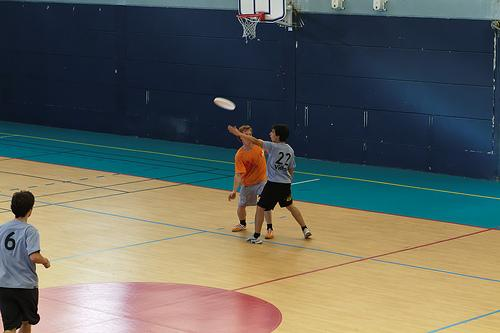What numbers are visible on the boys' shirts? Number 22 is on one boy's shirt, and number 6 is on the other boy's shirt. Give a simple description of the playing area. The playing area has a wooden, blue, red and green gymnasium floor, a green boundary line, and blue bleachers folded against the wall. Describe the scene involving the basketball hoop. There's a basketball hoop attached to the backboard on the wall, including a basketball net and an extended backboard. What colors are the boys' shirts, shorts, and shoes? One boy has an orange shirt, gray shorts, and orange sneakers, while the other has a gray shirt with number 6, black shorts, and blue sneakers. Mention the primary action in the image involving the frisbee. Two boys play with a frisbee, one of them throws it in the air while the third boy watches the game. Comment on the main action in the picture, including the tool used by both boys. Two boys are having fun with a white frisbee while another boy watches them, as they enjoy their playtime in a gymnasium. Summarize the key features of the image in a concise way. The image shows two boys playing frisbee, another boy watching, and sports elements such as courts, basketball hoop, and uniforms. Describe the key elements of the image related to sports. A white airborne frisbee, two boys playing with it, a green and a red court, a basketball hoop, and the players' uniforms. 